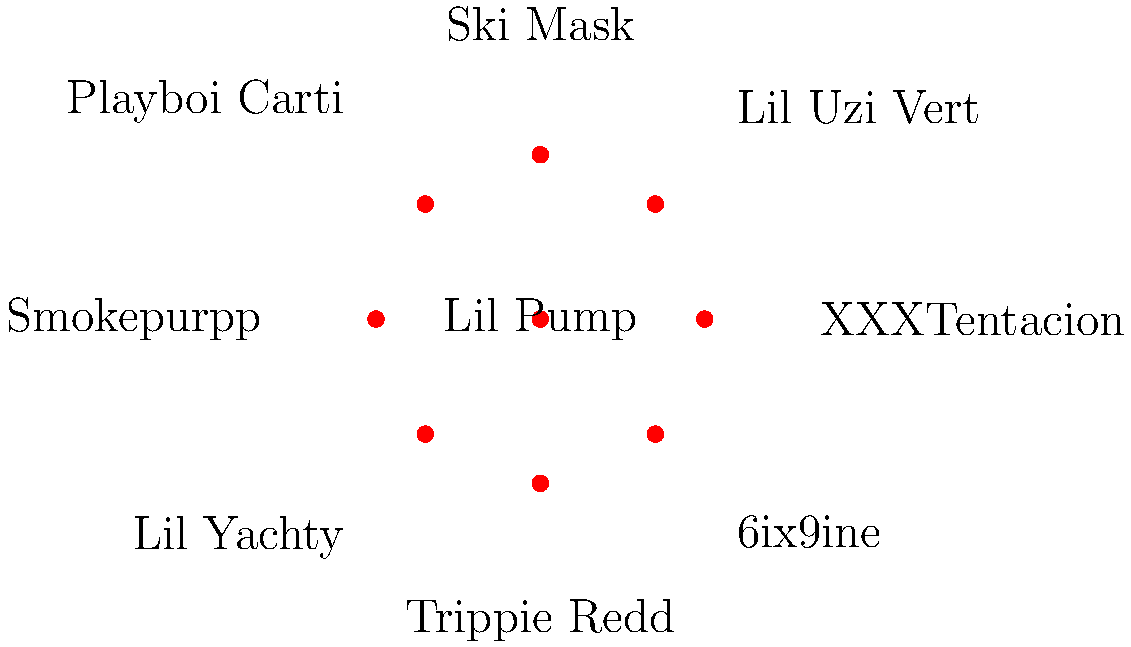In the polar force-directed graph representing the collaboration network of SoundCloud rappers, which artist appears to have the most connections (collaborations) with other artists? To determine which artist has the most connections in the graph, we need to follow these steps:

1. Identify each artist's node in the graph.
2. Count the number of lines (edges) connected to each node.
3. Compare the counts to find the highest number of connections.

Let's analyze each artist:

1. Lil Pump (center): 5 connections
2. XXXTentacion (right): 3 connections
3. Ski Mask (top): 4 connections
4. Smokepurpp (left): 3 connections
5. Trippie Redd (bottom): 3 connections
6. Lil Uzi Vert (top-right): 3 connections
7. Playboi Carti (top-left): 3 connections
8. Lil Yachty (bottom-left): 3 connections
9. 6ix9ine (bottom-right): 3 connections

After counting the connections for each artist, we can see that Lil Pump, positioned at the center of the graph, has the highest number of connections with 5 collaborations.
Answer: Lil Pump 